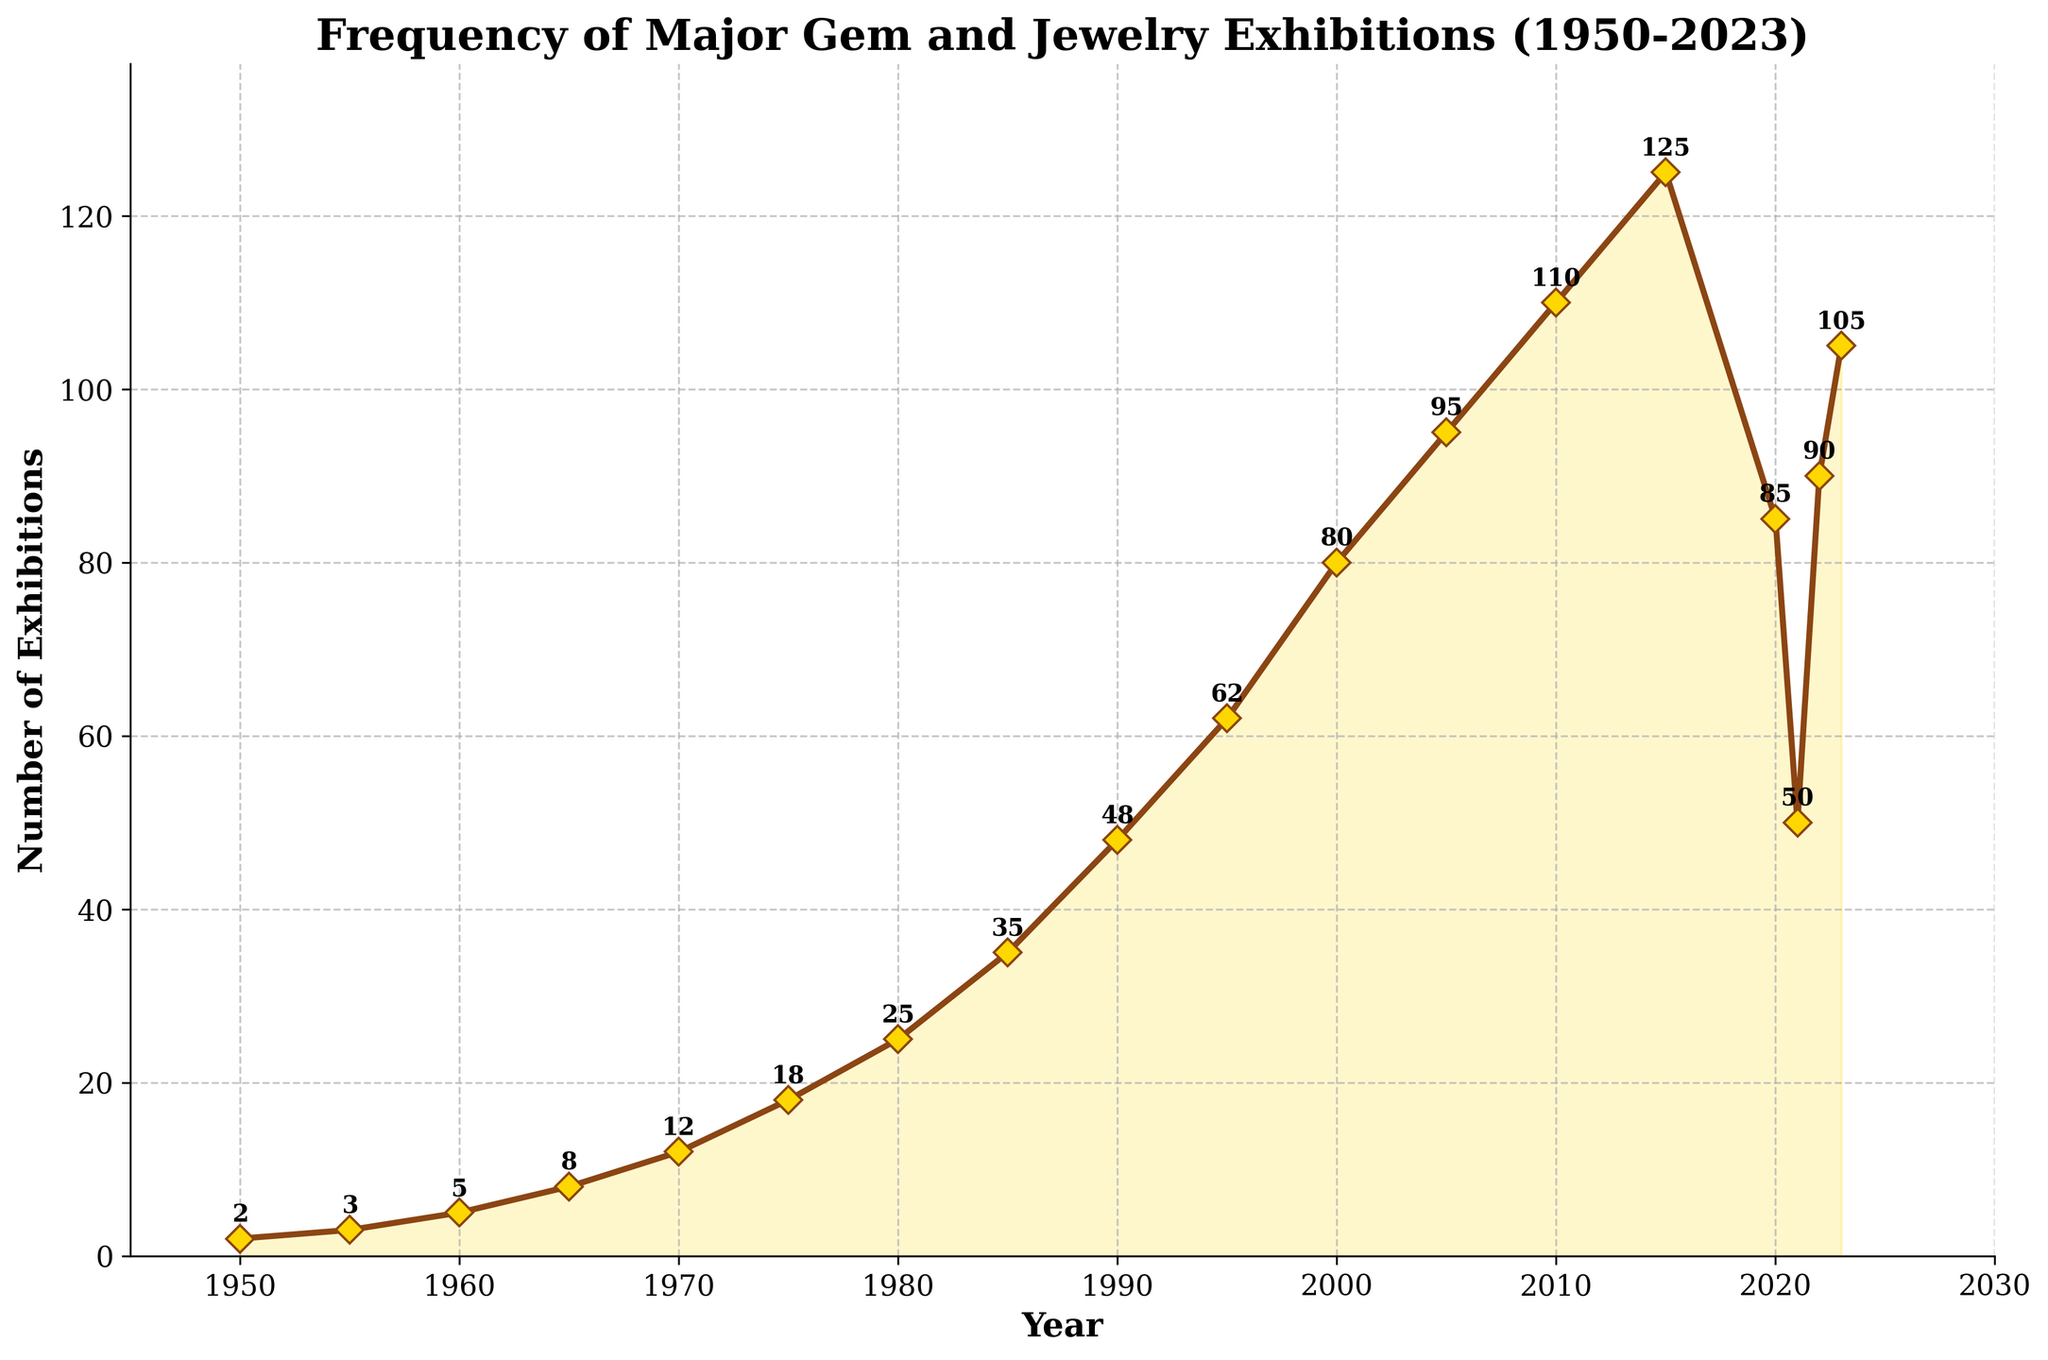What is the overall trend in the number of exhibitions from 1950 to 2023? The overall trend shows a significant increase in the frequency of major gem and jewelry exhibitions from 1950 to 2023, though there are some fluctuations. The number started from 2 exhibitions in 1950 and reached 105 in 2023.
Answer: Increase Which year had the highest number of exhibitions? By examining the peak points on the line chart and the annotated data points, the year 2015 had the highest number of exhibitions, marking 125 exhibitions.
Answer: 2015 How did the number of exhibitions change between 2015 and 2021? In 2015, there were 125 exhibitions. By 2021, the number of exhibitions decreased to 50. This indicates a decline of 75 exhibitions over these six years.
Answer: Decreased by 75 Which years show a noticeable drop in the number of exhibitions? Notably, the years 2020 and 2021 show a significant drop in exhibitions compared to other years, with a decrease from 125 in 2015 to 85 in 2020 and further down to 50 in 2021.
Answer: 2020 and 2021 What is the average number of exhibitions from 1950 to 2023? To find the average, sum the total number of exhibitions for each year provided and divide by the total number of years. The sum is 1068, and there are 17 data points. Hence, the average is 1068 / 17 ≈ 62.82.
Answer: 62.82 Compare the number of exhibitions in 1965 and 1985. What is the difference? In 1965, there were 8 exhibitions, and in 1985, there were 35 exhibitions. The difference between these two years is 35 - 8 = 27.
Answer: 27 Describe the trend between 2010 and 2015. From 2010 to 2015, there is a noticeable upward trend. The number of exhibitions increased from 110 in 2010 to 125 in 2015, indicating a growth of 15 exhibitions.
Answer: Upward trend What color represents the line and markers on the chart? The line and markers on the chart are depicted in a brownish color (saddle brown) with golden yellow markers at data points.
Answer: Brown line with golden yellow markers What type of trend is observed between 1950 and 2005? Between 1950 and 2005, the trend reveals a consistent and substantial increase in the number of exhibitions with no major declines. Exhibitions rose from 2 in 1950 to 95 in 2005.
Answer: Consistent increase 